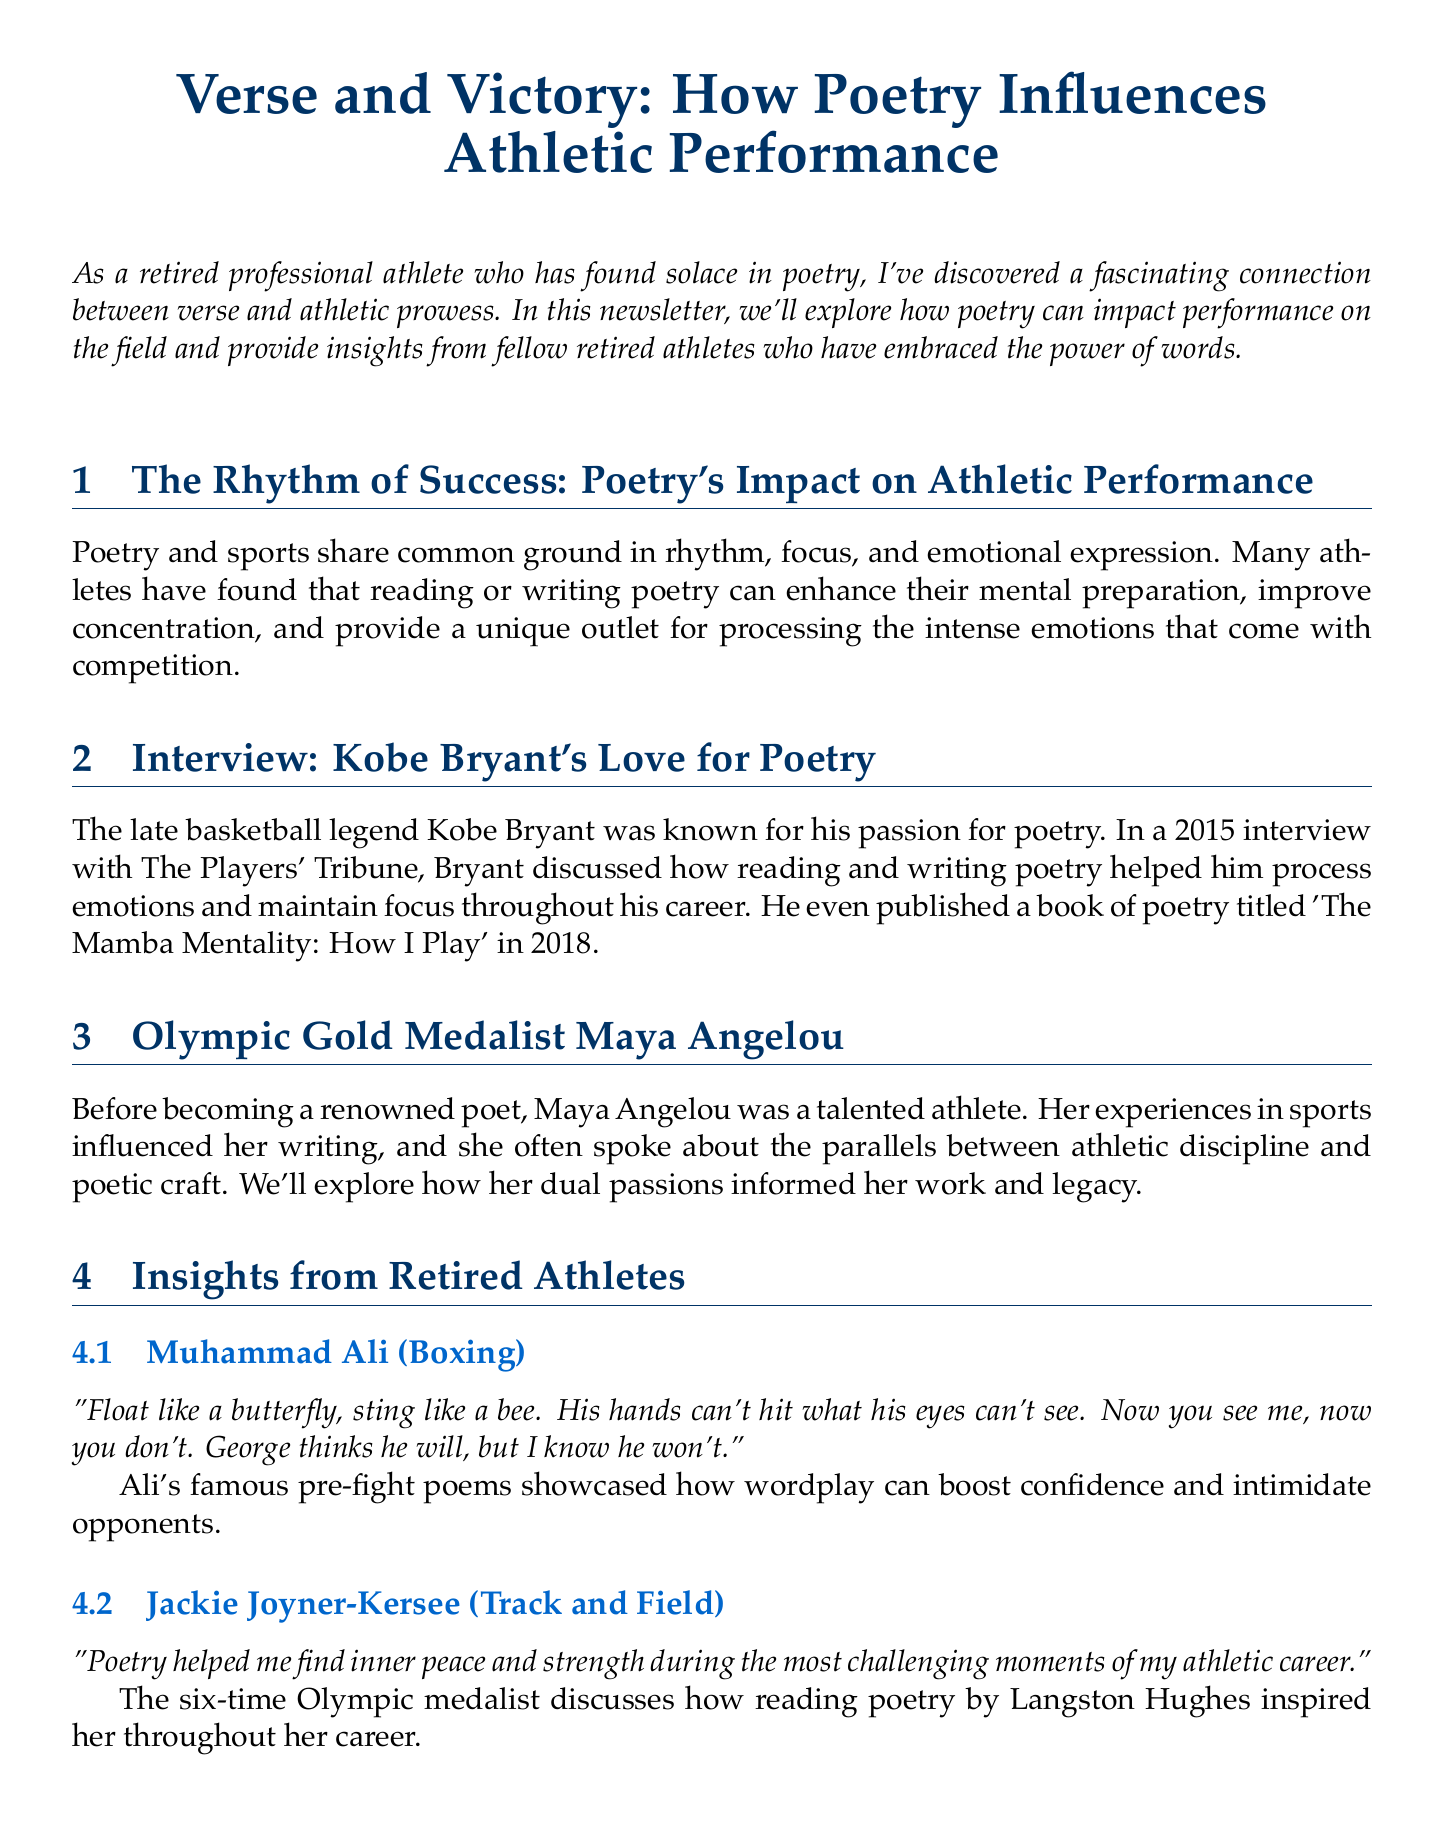What is the title of the newsletter? The title of the newsletter is mentioned at the beginning of the document.
Answer: Verse and Victory: How Poetry Influences Athletic Performance Who is interviewed about their love for poetry? The document lists an interview specifically about Kobe Bryant's passion for poetry.
Answer: Kobe Bryant Which athlete mentioned poetry's impact during challenging moments? The quote in the document from Jackie Joyner-Kersee discusses finding strength through poetry.
Answer: Jackie Joyner-Kersee What sport does Muhammad Ali represent? The document identifies Muhammad Ali's sport in the interview section.
Answer: Boxing What is the featured poem in the 'Athlete's Verse' section? The title of the featured poem is listed in the poetry corner description.
Answer: To An Athlete Dying Young How many Olympic medals has Jackie Joyner-Kersee won? The document states that Jackie Joyner-Kersee is a six-time Olympic medalist.
Answer: Six What did Pat Summitt use poetry for with her team? The document explains how Pat Summitt shared poems to motivate her players.
Answer: Inspire Who authored "What I Talk About When I Talk About Running"? This book is mentioned in the Further Reading section of the document.
Answer: Haruki Murakami What year did Kobe Bryant publish his book of poetry? The document provides the publication year of Kobe Bryant's poetry book.
Answer: 2018 